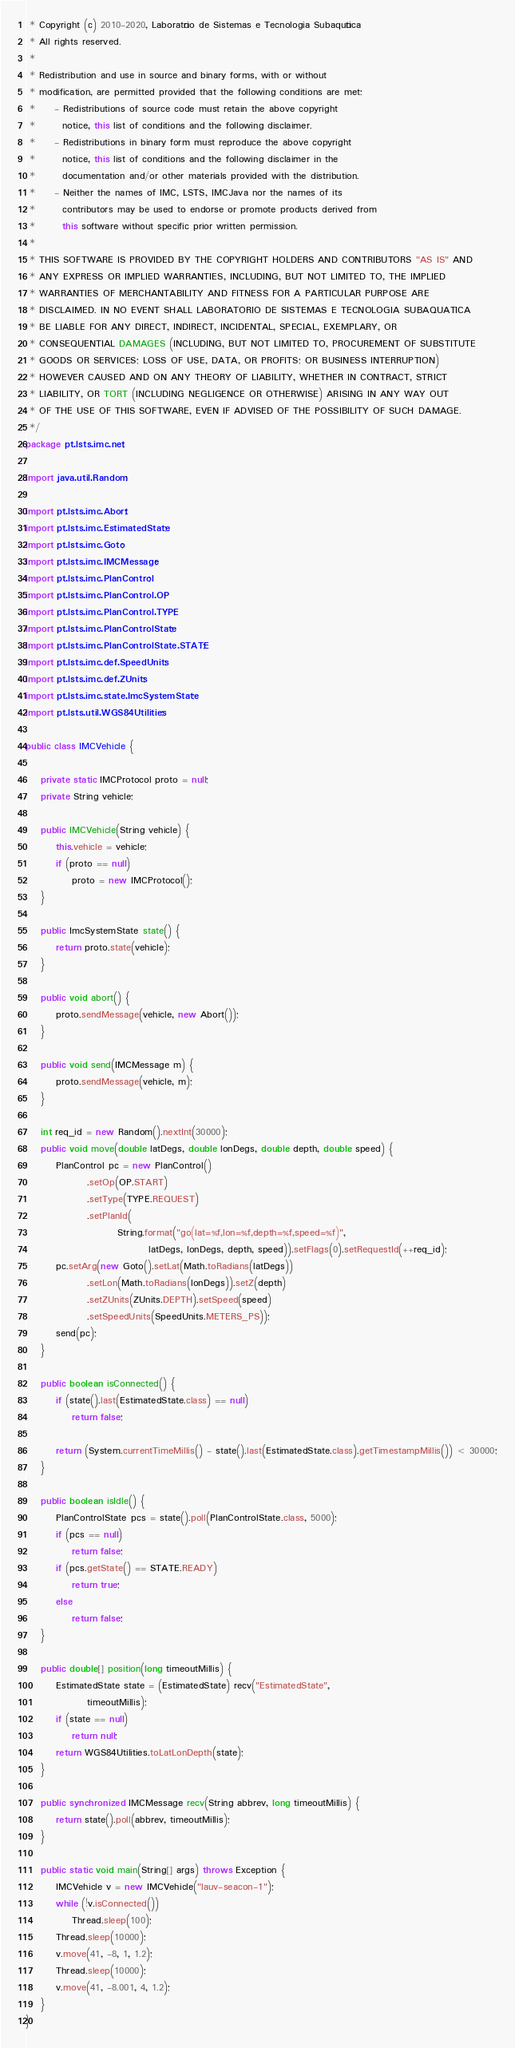Convert code to text. <code><loc_0><loc_0><loc_500><loc_500><_Java_> * Copyright (c) 2010-2020, Laboratório de Sistemas e Tecnologia Subaquática
 * All rights reserved.
 * 
 * Redistribution and use in source and binary forms, with or without
 * modification, are permitted provided that the following conditions are met:
 *     - Redistributions of source code must retain the above copyright
 *       notice, this list of conditions and the following disclaimer.
 *     - Redistributions in binary form must reproduce the above copyright
 *       notice, this list of conditions and the following disclaimer in the
 *       documentation and/or other materials provided with the distribution.
 *     - Neither the names of IMC, LSTS, IMCJava nor the names of its 
 *       contributors may be used to endorse or promote products derived from 
 *       this software without specific prior written permission.
 * 
 * THIS SOFTWARE IS PROVIDED BY THE COPYRIGHT HOLDERS AND CONTRIBUTORS "AS IS" AND
 * ANY EXPRESS OR IMPLIED WARRANTIES, INCLUDING, BUT NOT LIMITED TO, THE IMPLIED
 * WARRANTIES OF MERCHANTABILITY AND FITNESS FOR A PARTICULAR PURPOSE ARE
 * DISCLAIMED. IN NO EVENT SHALL LABORATORIO DE SISTEMAS E TECNOLOGIA SUBAQUATICA
 * BE LIABLE FOR ANY DIRECT, INDIRECT, INCIDENTAL, SPECIAL, EXEMPLARY, OR
 * CONSEQUENTIAL DAMAGES (INCLUDING, BUT NOT LIMITED TO, PROCUREMENT OF SUBSTITUTE 
 * GOODS OR SERVICES; LOSS OF USE, DATA, OR PROFITS; OR BUSINESS INTERRUPTION) 
 * HOWEVER CAUSED AND ON ANY THEORY OF LIABILITY, WHETHER IN CONTRACT, STRICT 
 * LIABILITY, OR TORT (INCLUDING NEGLIGENCE OR OTHERWISE) ARISING IN ANY WAY OUT 
 * OF THE USE OF THIS SOFTWARE, EVEN IF ADVISED OF THE POSSIBILITY OF SUCH DAMAGE.
 */
package pt.lsts.imc.net;

import java.util.Random;

import pt.lsts.imc.Abort;
import pt.lsts.imc.EstimatedState;
import pt.lsts.imc.Goto;
import pt.lsts.imc.IMCMessage;
import pt.lsts.imc.PlanControl;
import pt.lsts.imc.PlanControl.OP;
import pt.lsts.imc.PlanControl.TYPE;
import pt.lsts.imc.PlanControlState;
import pt.lsts.imc.PlanControlState.STATE;
import pt.lsts.imc.def.SpeedUnits;
import pt.lsts.imc.def.ZUnits;
import pt.lsts.imc.state.ImcSystemState;
import pt.lsts.util.WGS84Utilities;

public class IMCVehicle {

	private static IMCProtocol proto = null;
	private String vehicle;

	public IMCVehicle(String vehicle) {
		this.vehicle = vehicle;
		if (proto == null)
			proto = new IMCProtocol();
	}

	public ImcSystemState state() {
		return proto.state(vehicle);
	}

	public void abort() {
		proto.sendMessage(vehicle, new Abort());
	}

	public void send(IMCMessage m) {
		proto.sendMessage(vehicle, m);
	}

	int req_id = new Random().nextInt(30000);
	public void move(double latDegs, double lonDegs, double depth, double speed) {
		PlanControl pc = new PlanControl()
				.setOp(OP.START)
				.setType(TYPE.REQUEST)
				.setPlanId(
						String.format("go(lat=%f,lon=%f,depth=%f,speed=%f)",
								latDegs, lonDegs, depth, speed)).setFlags(0).setRequestId(++req_id);
		pc.setArg(new Goto().setLat(Math.toRadians(latDegs))
				.setLon(Math.toRadians(lonDegs)).setZ(depth)
				.setZUnits(ZUnits.DEPTH).setSpeed(speed)
				.setSpeedUnits(SpeedUnits.METERS_PS));
		send(pc);
	}
	
	public boolean isConnected() {
		if (state().last(EstimatedState.class) == null)
			return false;
		
		return (System.currentTimeMillis() - state().last(EstimatedState.class).getTimestampMillis()) < 30000;
	}

	public boolean isIdle() {
		PlanControlState pcs = state().poll(PlanControlState.class, 5000);
		if (pcs == null)
			return false;
		if (pcs.getState() == STATE.READY)
			return true;
		else
			return false;
	}

	public double[] position(long timeoutMillis) {
		EstimatedState state = (EstimatedState) recv("EstimatedState",
				timeoutMillis);
		if (state == null)
			return null;
		return WGS84Utilities.toLatLonDepth(state);
	}

	public synchronized IMCMessage recv(String abbrev, long timeoutMillis) {
		return state().poll(abbrev, timeoutMillis);
	}
	
	public static void main(String[] args) throws Exception {
		IMCVehicle v = new IMCVehicle("lauv-seacon-1");
		while (!v.isConnected())			
			Thread.sleep(100);
		Thread.sleep(10000);
		v.move(41, -8, 1, 1.2);
		Thread.sleep(10000);
		v.move(41, -8.001, 4, 1.2);
	}
}
</code> 